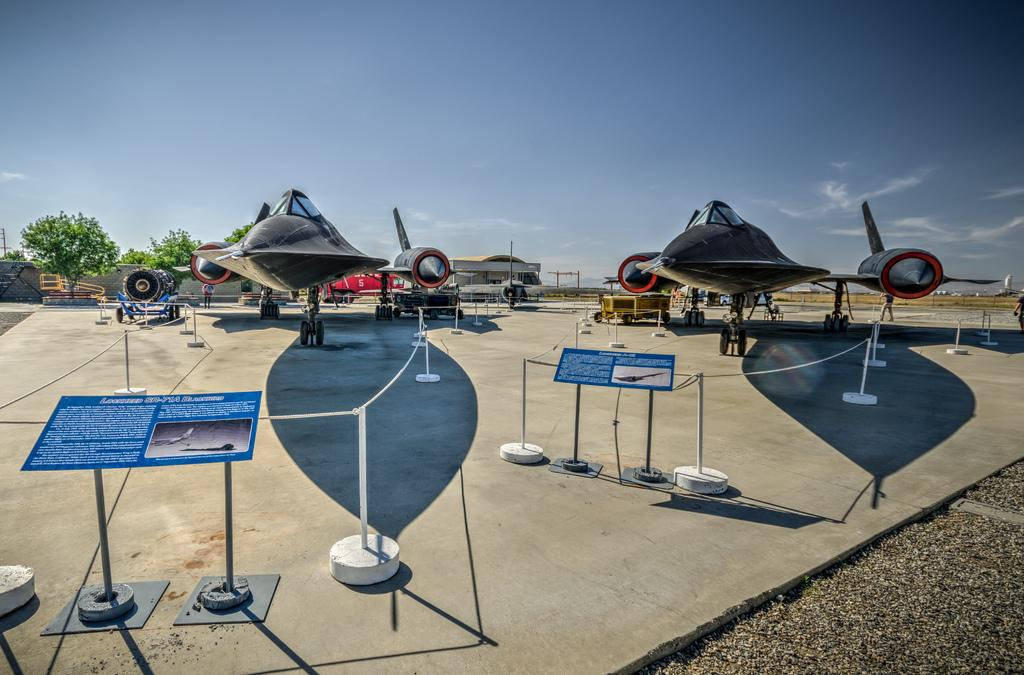How many people are present in the image? There are people in the image, but the exact number is not specified. What can be seen on the boards in the image? There are boards with text in the image. What type of barrier is present in the image? There is fencing in the image. What type of vehicles are in the image? There are aircrafts in the image. What type of vegetation is visible in the image? There are trees in the image. What type of structure is present in the image? There is a building in the image. What part of the natural environment is visible in the image? The sky is visible in the image. What type of tank can be seen in the image? There is no tank present in the image. What type of voice can be heard coming from the building in the image? There is no indication of any sound or voice in the image. 